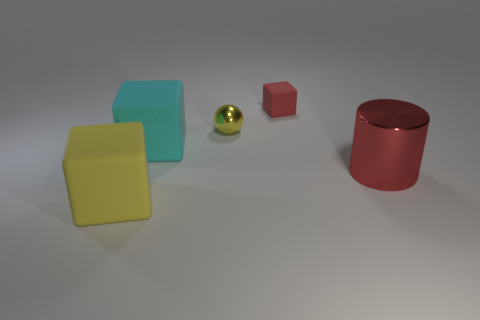Are there the same number of cyan blocks that are to the right of the large red shiny object and big matte things?
Keep it short and to the point. No. Are there any big red metallic objects in front of the big yellow matte thing?
Give a very brief answer. No. Does the tiny red thing have the same shape as the shiny thing that is left of the red rubber object?
Provide a short and direct response. No. What is the color of the tiny object that is the same material as the large cylinder?
Your answer should be very brief. Yellow. Is the number of red matte things the same as the number of small purple metallic objects?
Make the answer very short. No. What is the color of the tiny shiny object?
Provide a short and direct response. Yellow. Are the small ball and the yellow object that is in front of the small yellow metallic sphere made of the same material?
Offer a terse response. No. How many yellow things are in front of the tiny yellow metallic ball and right of the big cyan cube?
Offer a very short reply. 0. There is a thing that is the same size as the red matte cube; what is its shape?
Keep it short and to the point. Sphere. There is a large rubber cube in front of the red thing that is in front of the red matte thing; are there any tiny yellow shiny objects that are in front of it?
Keep it short and to the point. No. 